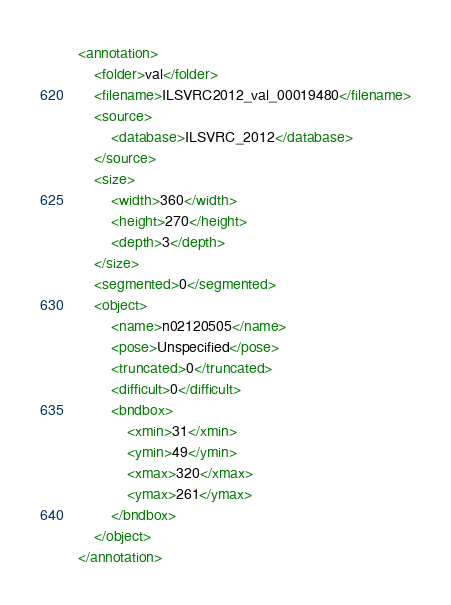Convert code to text. <code><loc_0><loc_0><loc_500><loc_500><_XML_><annotation>
	<folder>val</folder>
	<filename>ILSVRC2012_val_00019480</filename>
	<source>
		<database>ILSVRC_2012</database>
	</source>
	<size>
		<width>360</width>
		<height>270</height>
		<depth>3</depth>
	</size>
	<segmented>0</segmented>
	<object>
		<name>n02120505</name>
		<pose>Unspecified</pose>
		<truncated>0</truncated>
		<difficult>0</difficult>
		<bndbox>
			<xmin>31</xmin>
			<ymin>49</ymin>
			<xmax>320</xmax>
			<ymax>261</ymax>
		</bndbox>
	</object>
</annotation></code> 